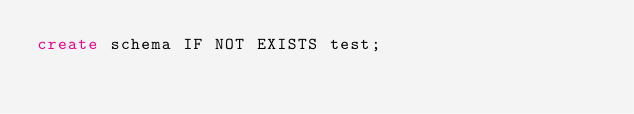<code> <loc_0><loc_0><loc_500><loc_500><_SQL_>create schema IF NOT EXISTS test;
</code> 